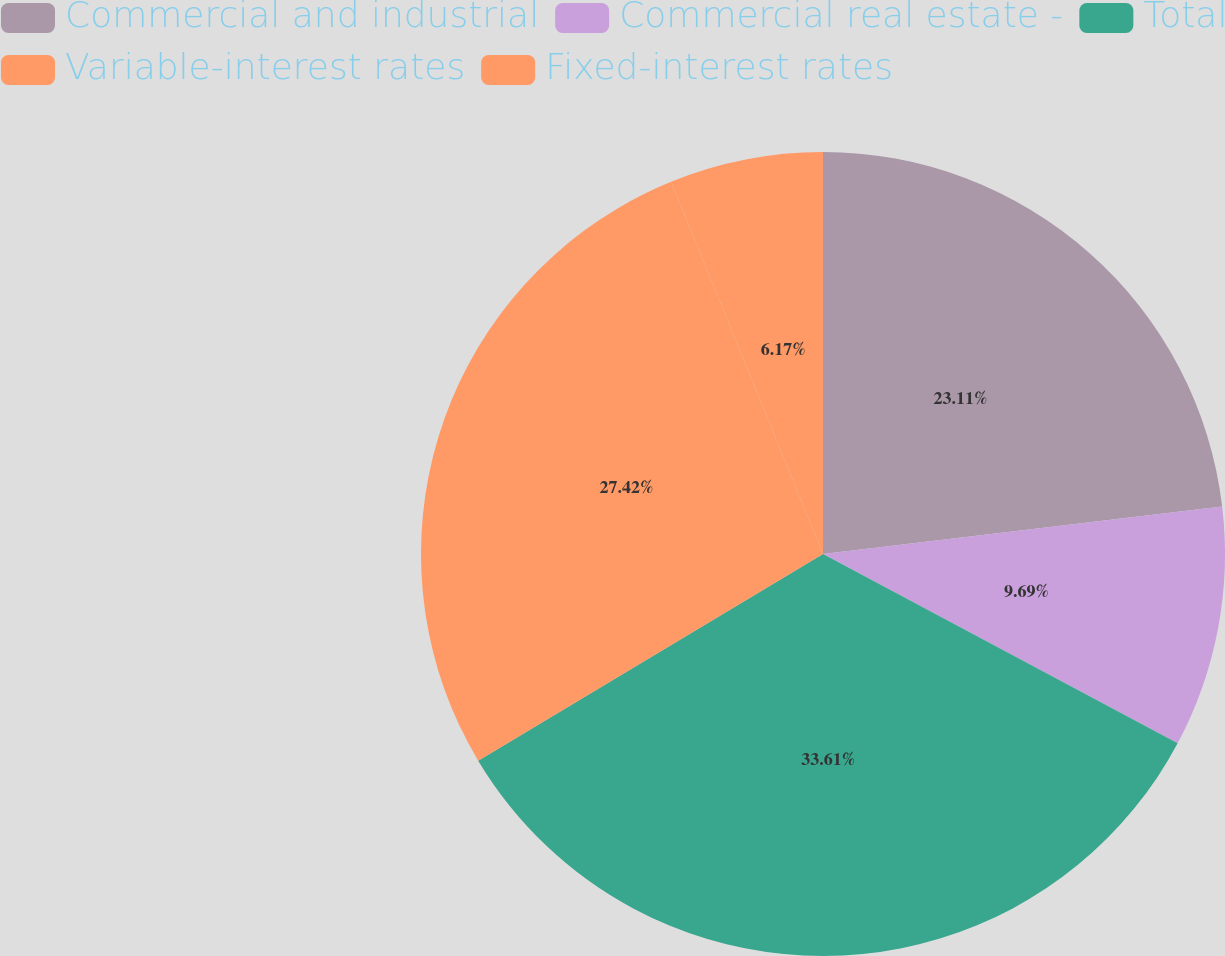Convert chart. <chart><loc_0><loc_0><loc_500><loc_500><pie_chart><fcel>Commercial and industrial<fcel>Commercial real estate -<fcel>Total<fcel>Variable-interest rates<fcel>Fixed-interest rates<nl><fcel>23.11%<fcel>9.69%<fcel>33.6%<fcel>27.42%<fcel>6.17%<nl></chart> 